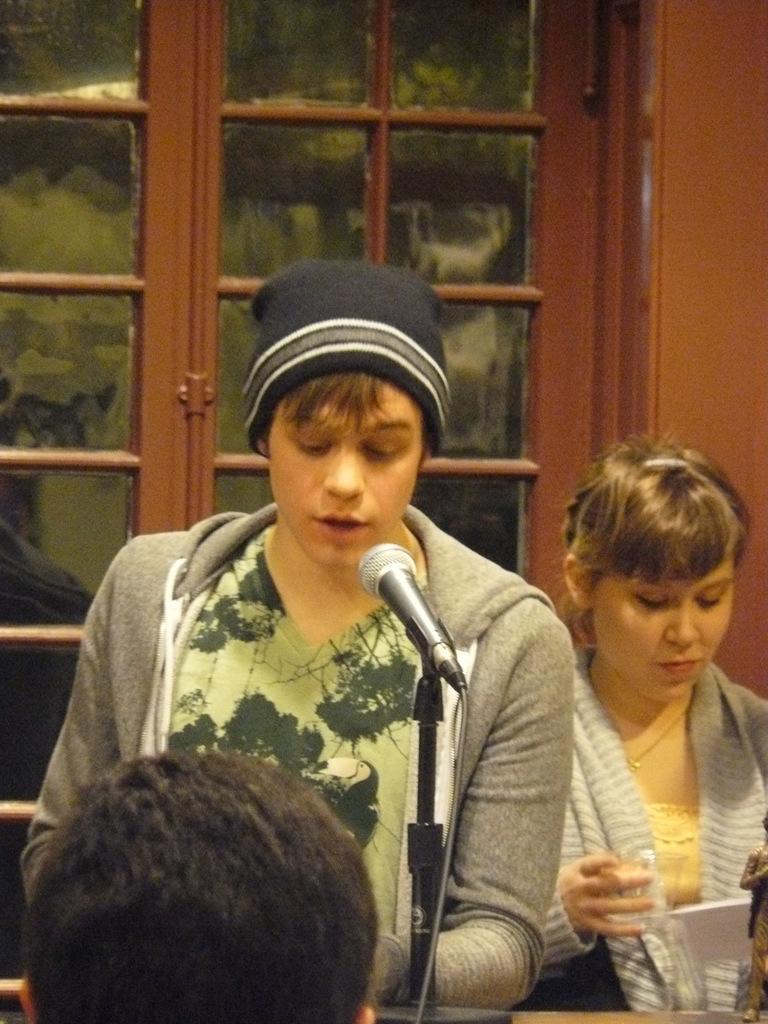In one or two sentences, can you explain what this image depicts? In the image there is a head of a person the foreground, behind the person there are two people and there is a mic in front of one person among them and in the background there is a door. 